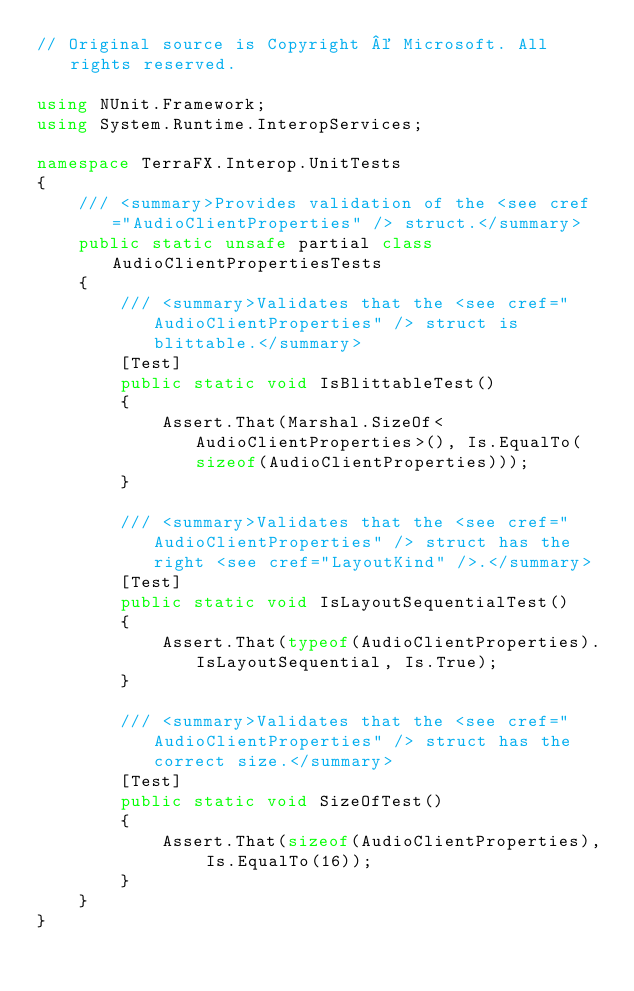Convert code to text. <code><loc_0><loc_0><loc_500><loc_500><_C#_>// Original source is Copyright © Microsoft. All rights reserved.

using NUnit.Framework;
using System.Runtime.InteropServices;

namespace TerraFX.Interop.UnitTests
{
    /// <summary>Provides validation of the <see cref="AudioClientProperties" /> struct.</summary>
    public static unsafe partial class AudioClientPropertiesTests
    {
        /// <summary>Validates that the <see cref="AudioClientProperties" /> struct is blittable.</summary>
        [Test]
        public static void IsBlittableTest()
        {
            Assert.That(Marshal.SizeOf<AudioClientProperties>(), Is.EqualTo(sizeof(AudioClientProperties)));
        }

        /// <summary>Validates that the <see cref="AudioClientProperties" /> struct has the right <see cref="LayoutKind" />.</summary>
        [Test]
        public static void IsLayoutSequentialTest()
        {
            Assert.That(typeof(AudioClientProperties).IsLayoutSequential, Is.True);
        }

        /// <summary>Validates that the <see cref="AudioClientProperties" /> struct has the correct size.</summary>
        [Test]
        public static void SizeOfTest()
        {
            Assert.That(sizeof(AudioClientProperties), Is.EqualTo(16));
        }
    }
}
</code> 